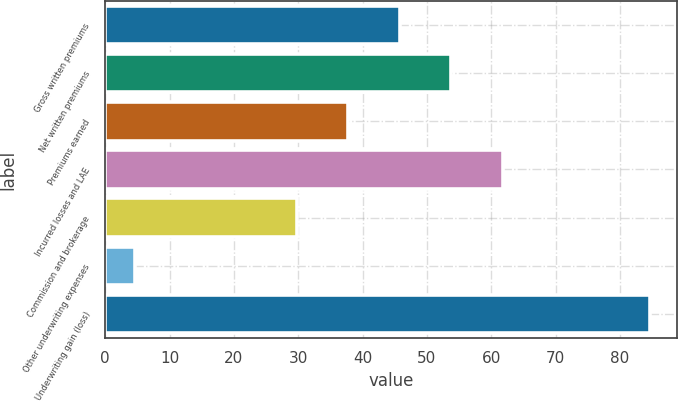Convert chart. <chart><loc_0><loc_0><loc_500><loc_500><bar_chart><fcel>Gross written premiums<fcel>Net written premiums<fcel>Premiums earned<fcel>Incurred losses and LAE<fcel>Commission and brokerage<fcel>Other underwriting expenses<fcel>Underwriting gain (loss)<nl><fcel>45.8<fcel>53.8<fcel>37.8<fcel>61.8<fcel>29.8<fcel>4.6<fcel>84.6<nl></chart> 